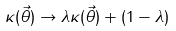Convert formula to latex. <formula><loc_0><loc_0><loc_500><loc_500>\kappa ( \vec { \theta } ) \to \lambda \kappa ( \vec { \theta } ) + ( 1 - \lambda )</formula> 